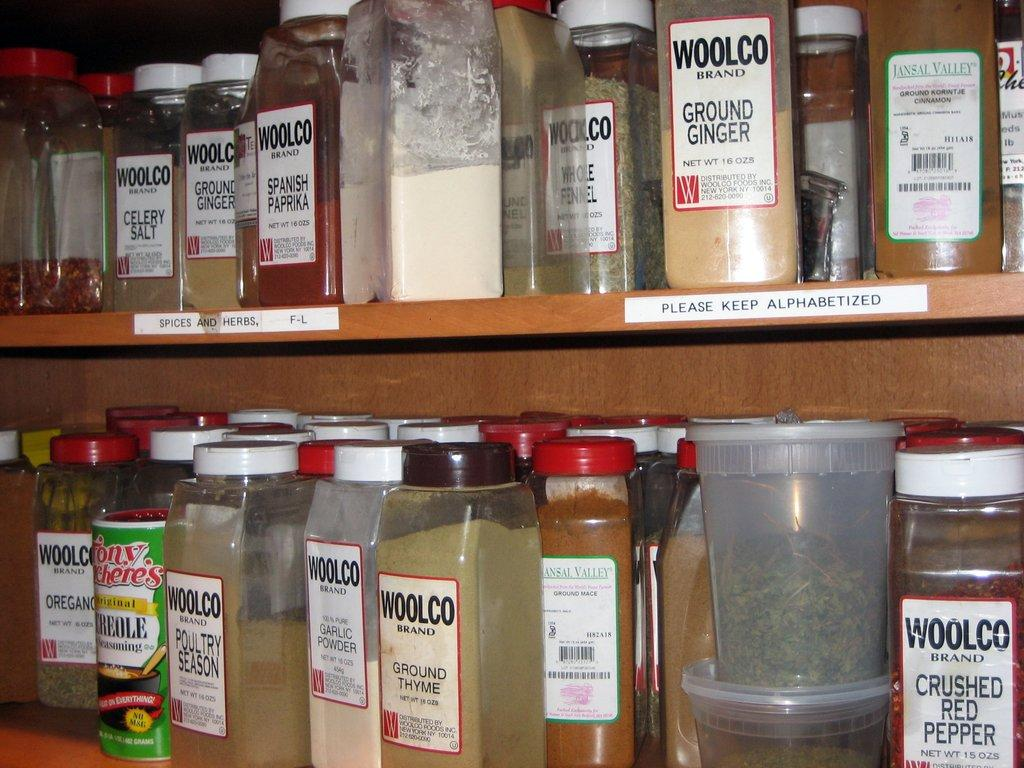What objects are present at the top and bottom of the image? There are containers at the top and bottom of the image. What are the containers used for? The containers hold groceries. Reasoning: Leting: Let's think step by step in order to produce the conversation. We start by identifying the main objects in the image, which are the containers. Then, we describe their purpose, which is to hold groceries. Each question is designed to elicit a specific detail about the image that is known from the provided facts. Absurd Question/Answer: What type of development is taking place in the image? There is no development taking place in the image; it only shows containers holding groceries. Can you see a vest in the image? There is no vest present in the image. What type of power is being generated in the image? There is no power generation taking place in the image; it only shows containers holding groceries. 